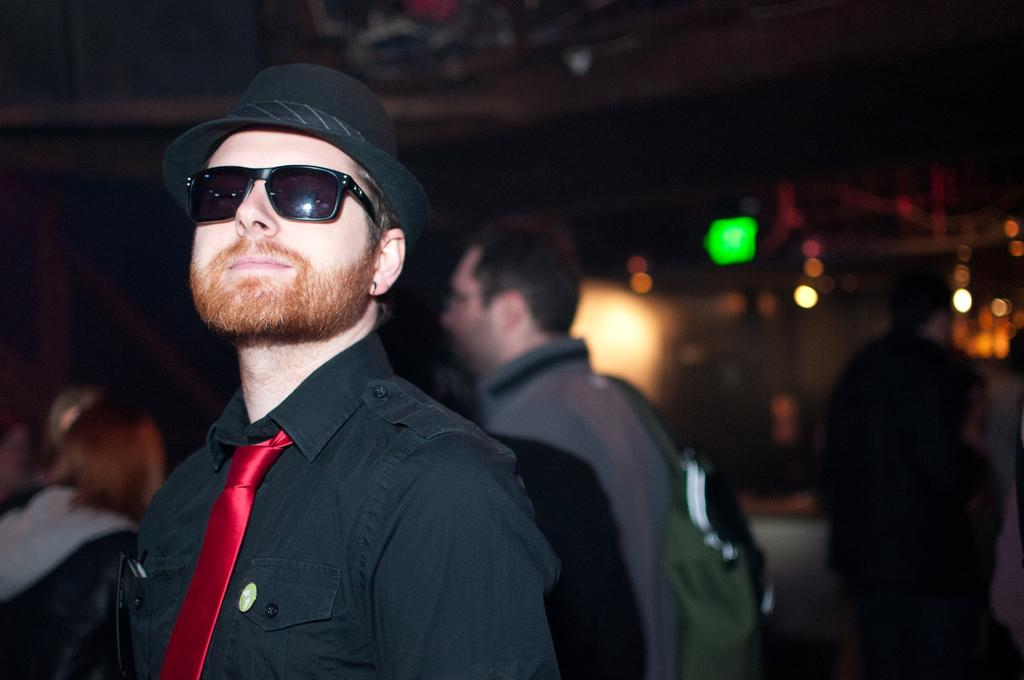Who is the main subject in the image? There is a man in the image. What accessories is the man wearing? The man is wearing glasses and a hat. What can be seen in the background of the image? There is a group of people in the background of the image. What is the source of illumination in the image? There are lights visible in the image. What is the distribution of the steps in the image? There are no steps present in the image. 